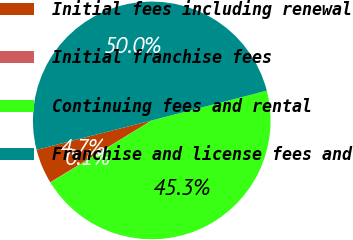Convert chart to OTSL. <chart><loc_0><loc_0><loc_500><loc_500><pie_chart><fcel>Initial fees including renewal<fcel>Initial franchise fees<fcel>Continuing fees and rental<fcel>Franchise and license fees and<nl><fcel>4.73%<fcel>0.05%<fcel>45.27%<fcel>49.95%<nl></chart> 